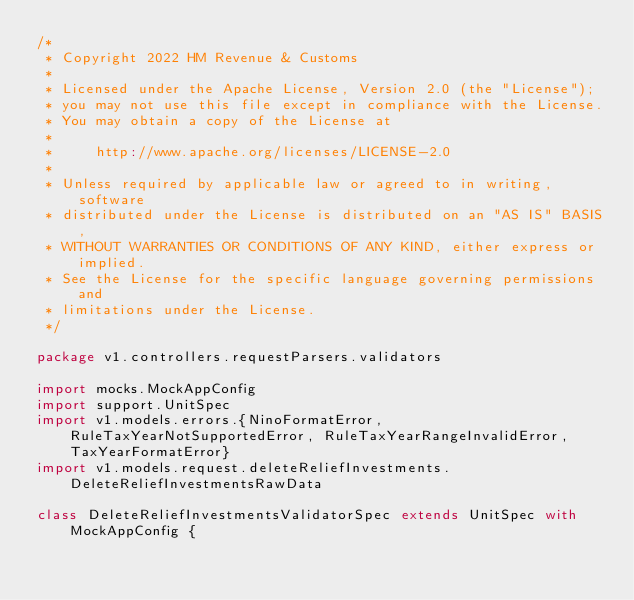<code> <loc_0><loc_0><loc_500><loc_500><_Scala_>/*
 * Copyright 2022 HM Revenue & Customs
 *
 * Licensed under the Apache License, Version 2.0 (the "License");
 * you may not use this file except in compliance with the License.
 * You may obtain a copy of the License at
 *
 *     http://www.apache.org/licenses/LICENSE-2.0
 *
 * Unless required by applicable law or agreed to in writing, software
 * distributed under the License is distributed on an "AS IS" BASIS,
 * WITHOUT WARRANTIES OR CONDITIONS OF ANY KIND, either express or implied.
 * See the License for the specific language governing permissions and
 * limitations under the License.
 */

package v1.controllers.requestParsers.validators

import mocks.MockAppConfig
import support.UnitSpec
import v1.models.errors.{NinoFormatError, RuleTaxYearNotSupportedError, RuleTaxYearRangeInvalidError, TaxYearFormatError}
import v1.models.request.deleteReliefInvestments.DeleteReliefInvestmentsRawData

class DeleteReliefInvestmentsValidatorSpec extends UnitSpec with MockAppConfig {
</code> 